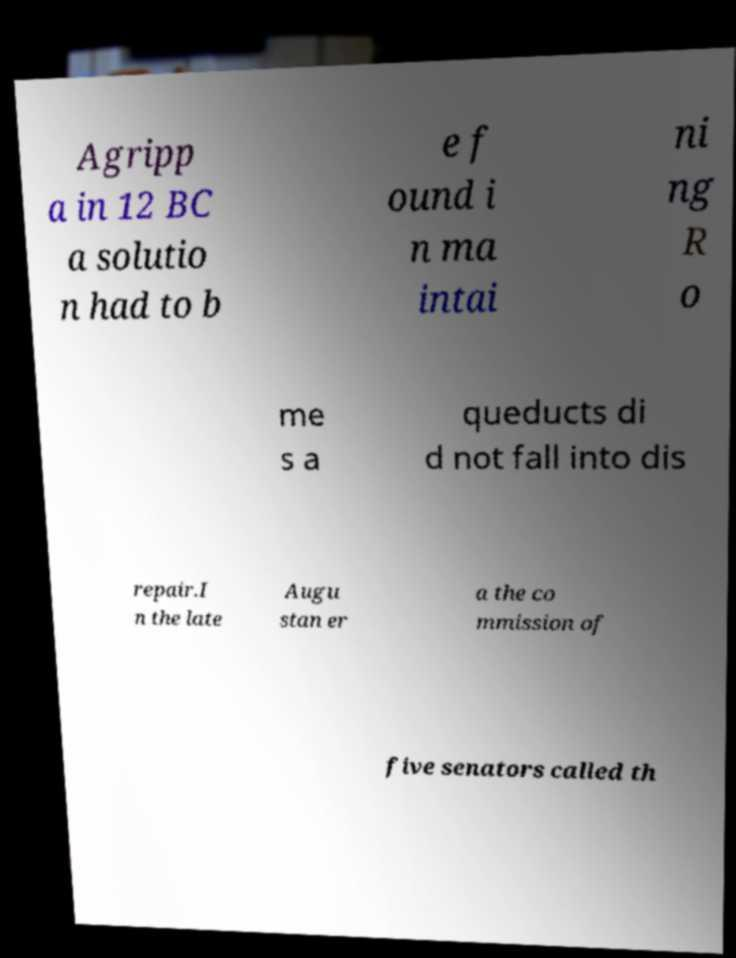I need the written content from this picture converted into text. Can you do that? Agripp a in 12 BC a solutio n had to b e f ound i n ma intai ni ng R o me s a queducts di d not fall into dis repair.I n the late Augu stan er a the co mmission of five senators called th 